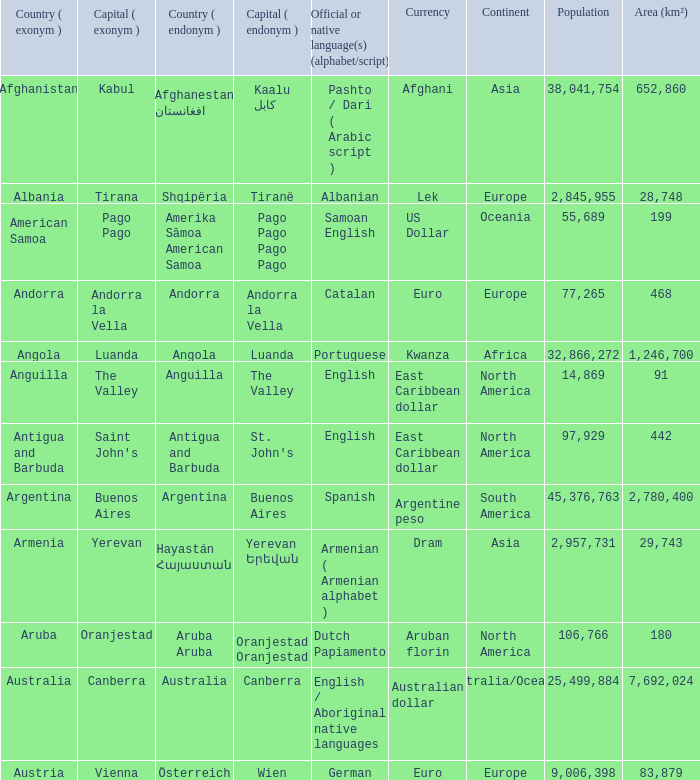What is the English name of the country whose official native language is Dutch Papiamento? Aruba. 